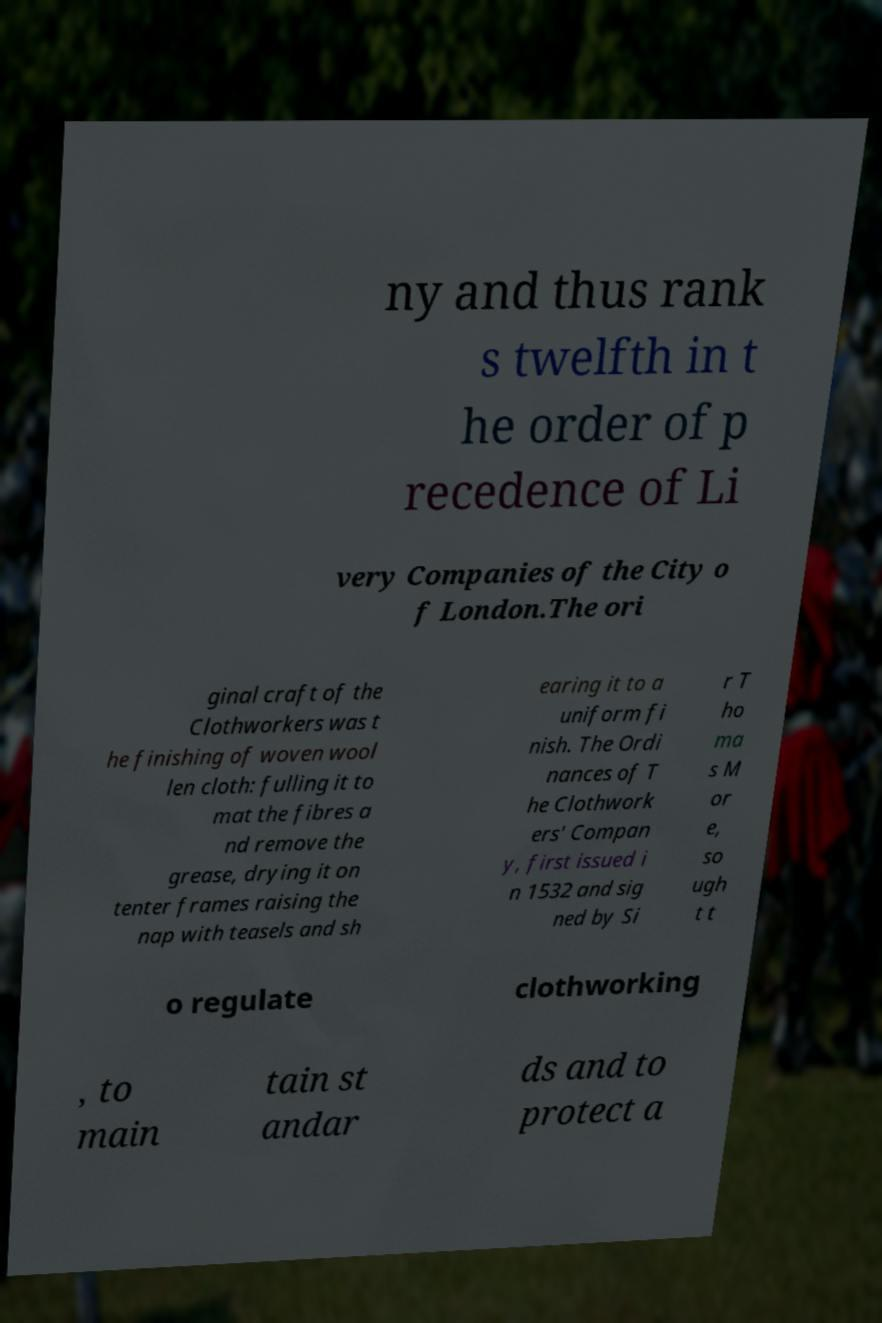For documentation purposes, I need the text within this image transcribed. Could you provide that? ny and thus rank s twelfth in t he order of p recedence of Li very Companies of the City o f London.The ori ginal craft of the Clothworkers was t he finishing of woven wool len cloth: fulling it to mat the fibres a nd remove the grease, drying it on tenter frames raising the nap with teasels and sh earing it to a uniform fi nish. The Ordi nances of T he Clothwork ers' Compan y, first issued i n 1532 and sig ned by Si r T ho ma s M or e, so ugh t t o regulate clothworking , to main tain st andar ds and to protect a 